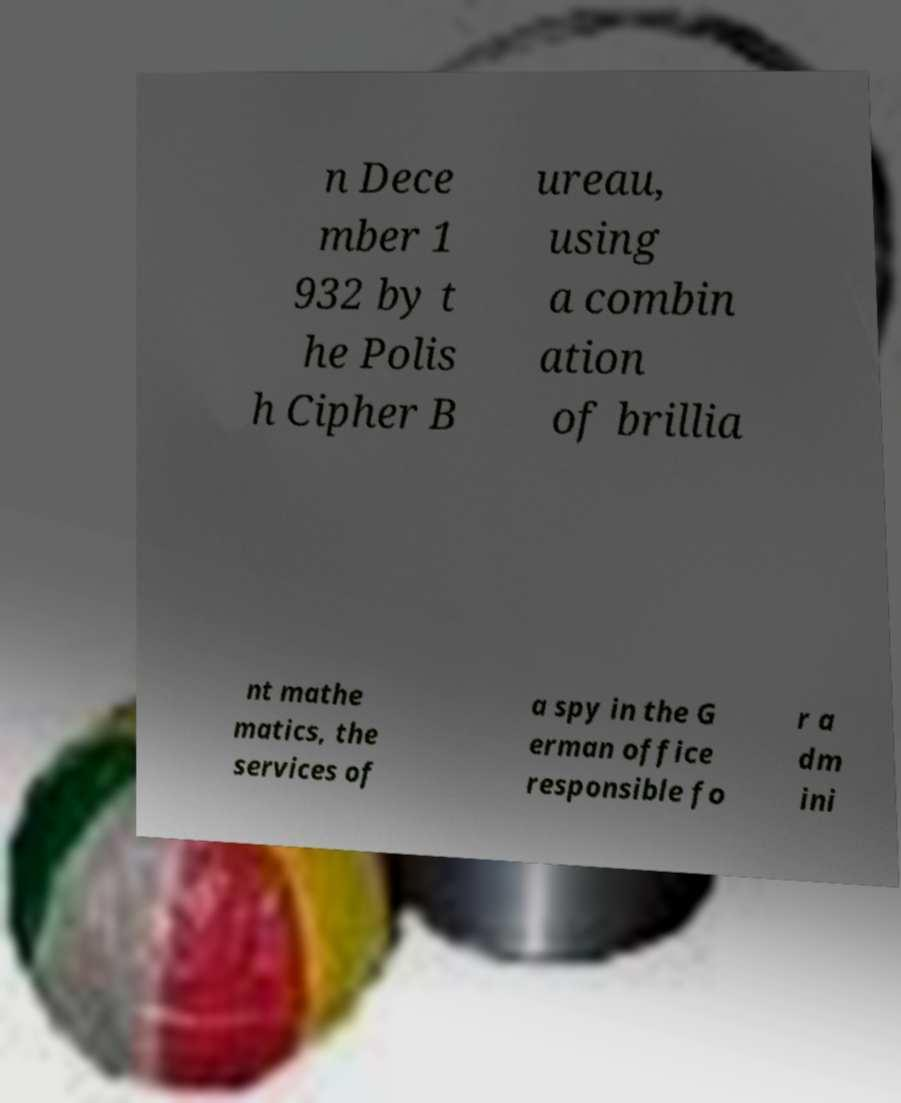For documentation purposes, I need the text within this image transcribed. Could you provide that? n Dece mber 1 932 by t he Polis h Cipher B ureau, using a combin ation of brillia nt mathe matics, the services of a spy in the G erman office responsible fo r a dm ini 